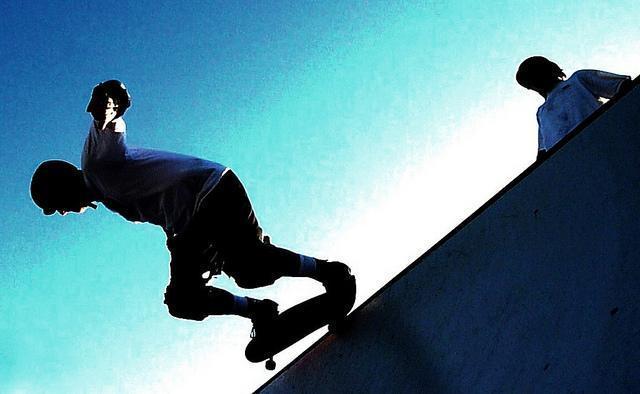How many people are there?
Give a very brief answer. 2. How many people can be seen?
Give a very brief answer. 2. How many black cars are in the picture?
Give a very brief answer. 0. 